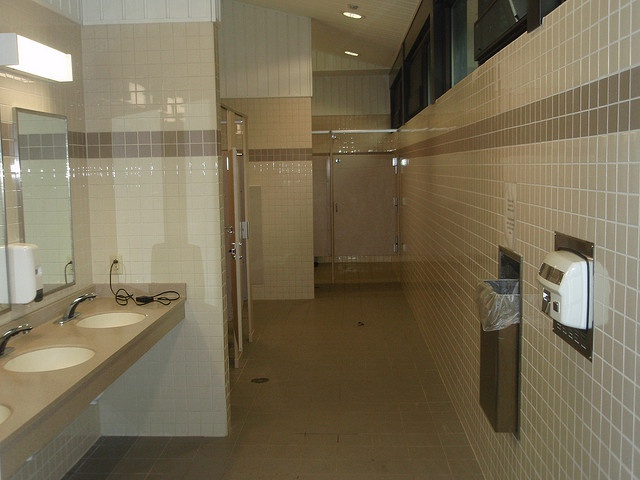Describe the objects in this image and their specific colors. I can see sink in gray and tan tones, sink in gray and tan tones, and sink in tan and gray tones in this image. 